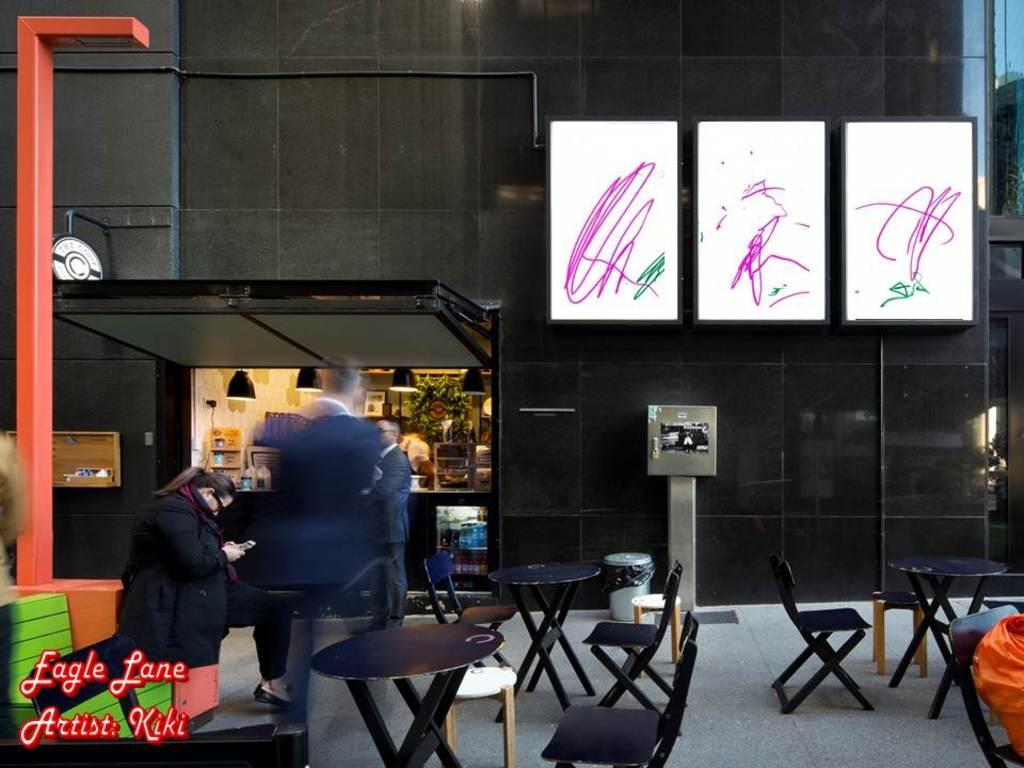Who or what is present in the image? There are people in the image. What furniture can be seen in the image? There are chairs in the image. How are the chairs arranged in the image? Tables are arranged in the image. What can be seen in the distance in the image? There is a shop visible in the background. What is on the wall in the image? There are boards on the wall. What color of paint is used on the ornament in the image? There is no ornament present in the image, and therefore no paint color can be determined. 